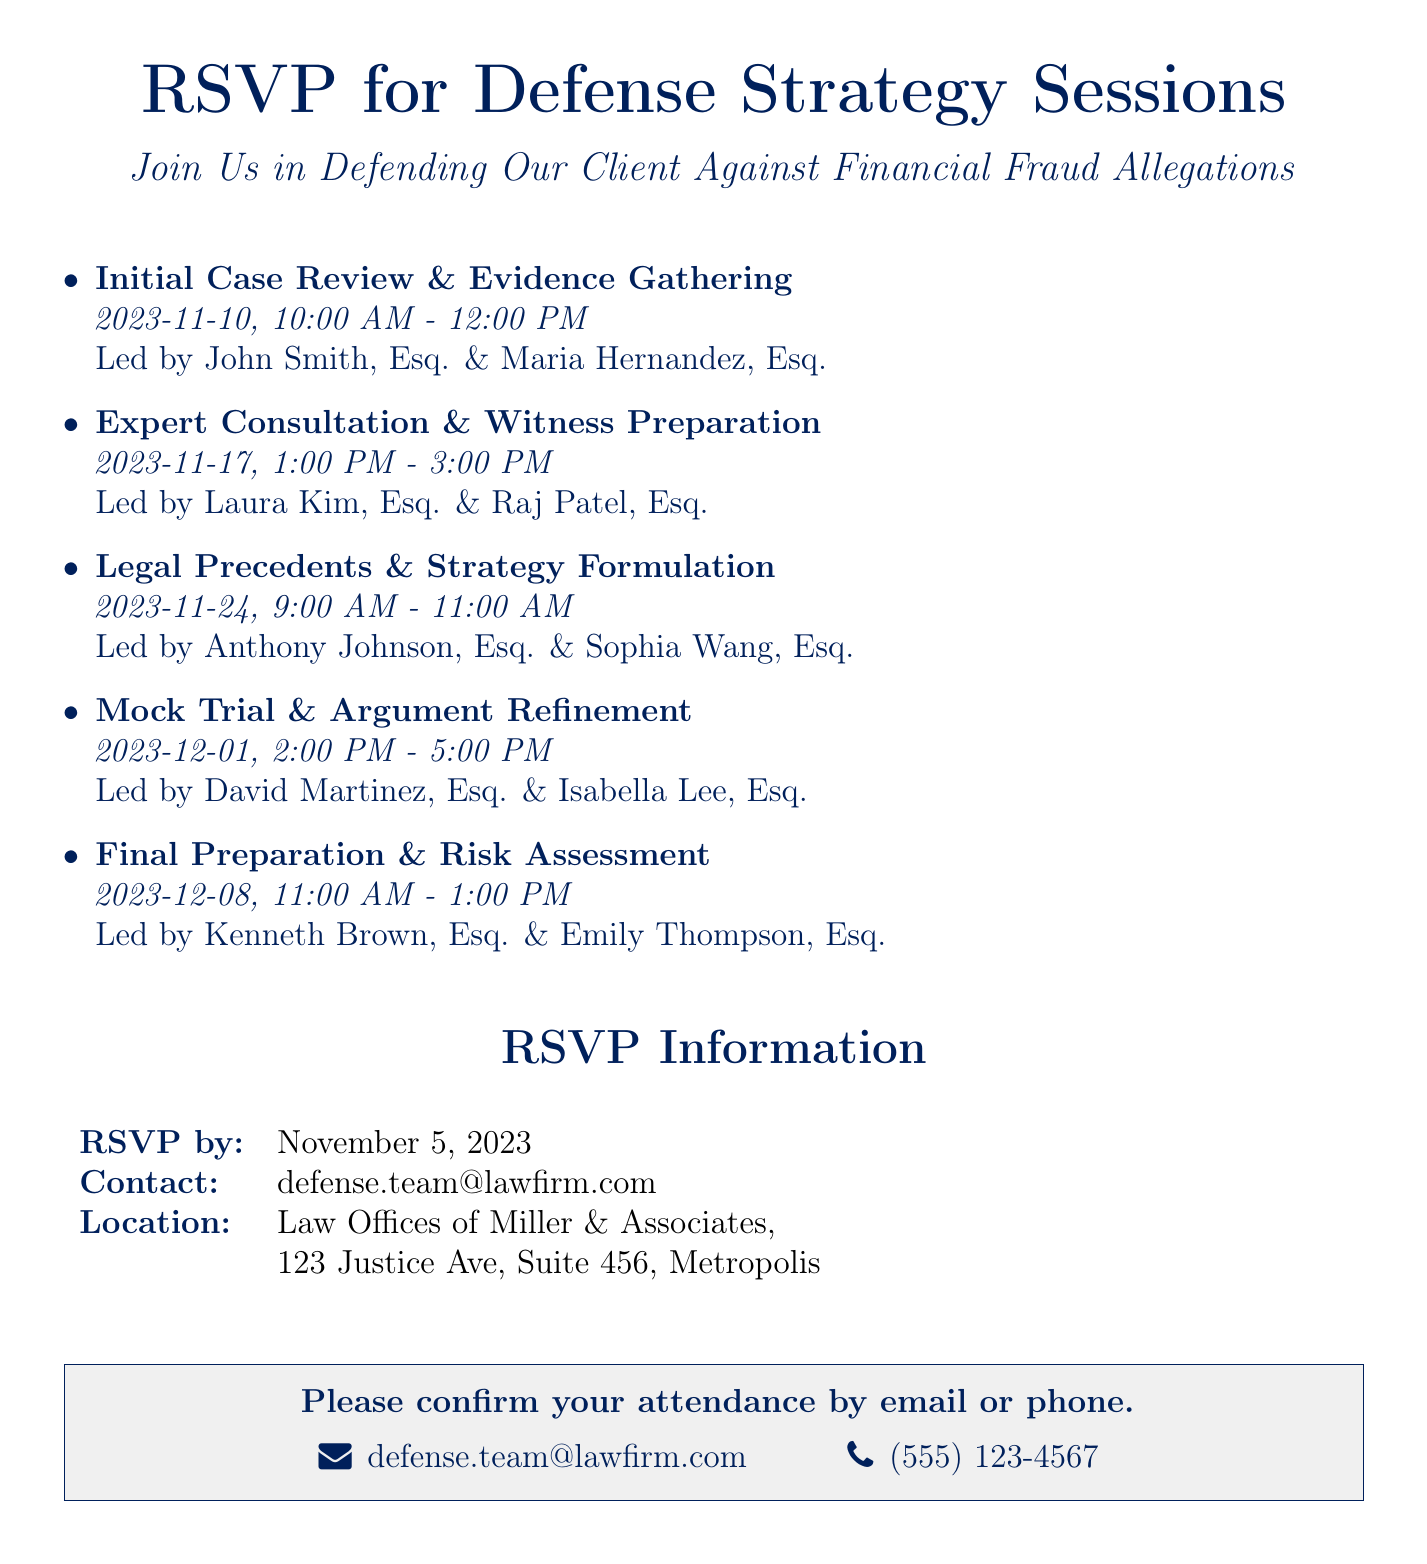What is the date of the Initial Case Review? The date for the Initial Case Review session is specified in the document as November 10, 2023.
Answer: November 10, 2023 Who is leading the Mock Trial session? The document lists David Martinez, Esq. and Isabella Lee, Esq. as the leaders for the Mock Trial session.
Answer: David Martinez, Esq. & Isabella Lee, Esq What time does the Final Preparation session start? The time for the Final Preparation session is mentioned as 11:00 AM.
Answer: 11:00 AM What is the RSVP deadline? The deadline for the RSVP is clearly indicated as November 5, 2023.
Answer: November 5, 2023 Where is the location of the sessions? The document provides the location as the Law Offices of Miller & Associates, 123 Justice Ave, Suite 456, Metropolis.
Answer: Law Offices of Miller & Associates, 123 Justice Ave, Suite 456, Metropolis How many strategy sessions are scheduled in total? By reviewing the sessions listed in the document, we can see that there are five strategy sessions scheduled.
Answer: Five What type of document is this? The content and structure suggest that this is an RSVP card for defense strategy sessions.
Answer: RSVP card What theme color is used in the document? The primary theme color throughout the document is navy blue.
Answer: Navy blue What is the contact email for RSVPs? The document states the contact email for RSVPs as defense.team@lawfirm.com.
Answer: defense.team@lawfirm.com 